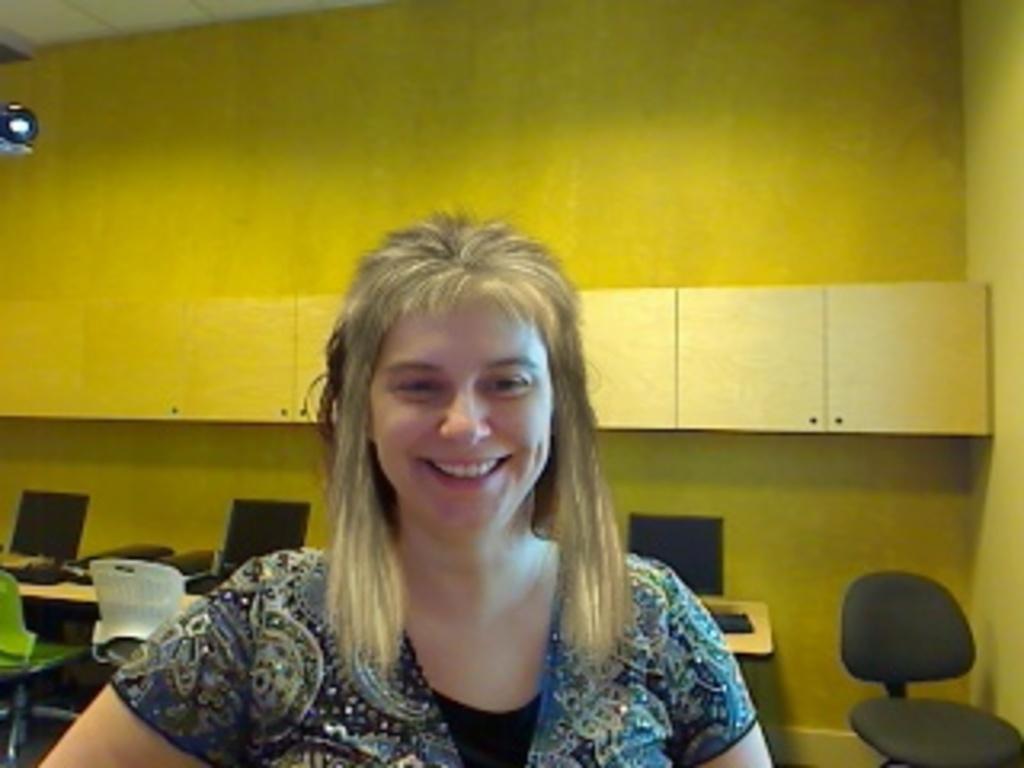In one or two sentences, can you explain what this image depicts? In this picture we can see a woman. She is smiling. On this background we can see wall. There are tables. On the table we can see monitor, keyboard. There are chairs. 